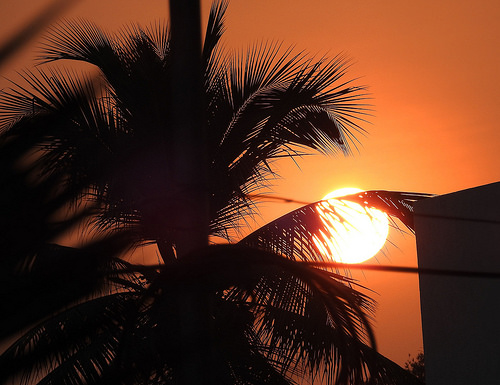<image>
Is the sun behind the tree? Yes. From this viewpoint, the sun is positioned behind the tree, with the tree partially or fully occluding the sun. 